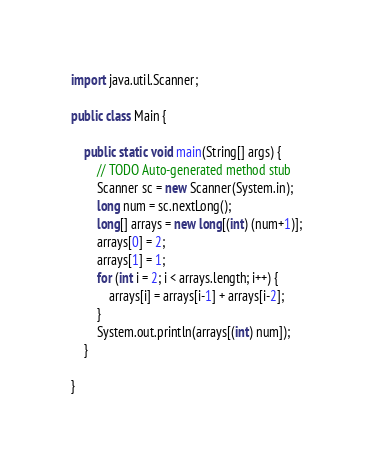<code> <loc_0><loc_0><loc_500><loc_500><_Java_>import java.util.Scanner;

public class Main {

	public static void main(String[] args) {
		// TODO Auto-generated method stub
		Scanner sc = new Scanner(System.in);
		long num = sc.nextLong();
		long[] arrays = new long[(int) (num+1)];
		arrays[0] = 2;
		arrays[1] = 1;
		for (int i = 2; i < arrays.length; i++) {
			arrays[i] = arrays[i-1] + arrays[i-2];
		}
		System.out.println(arrays[(int) num]);
	}

}</code> 